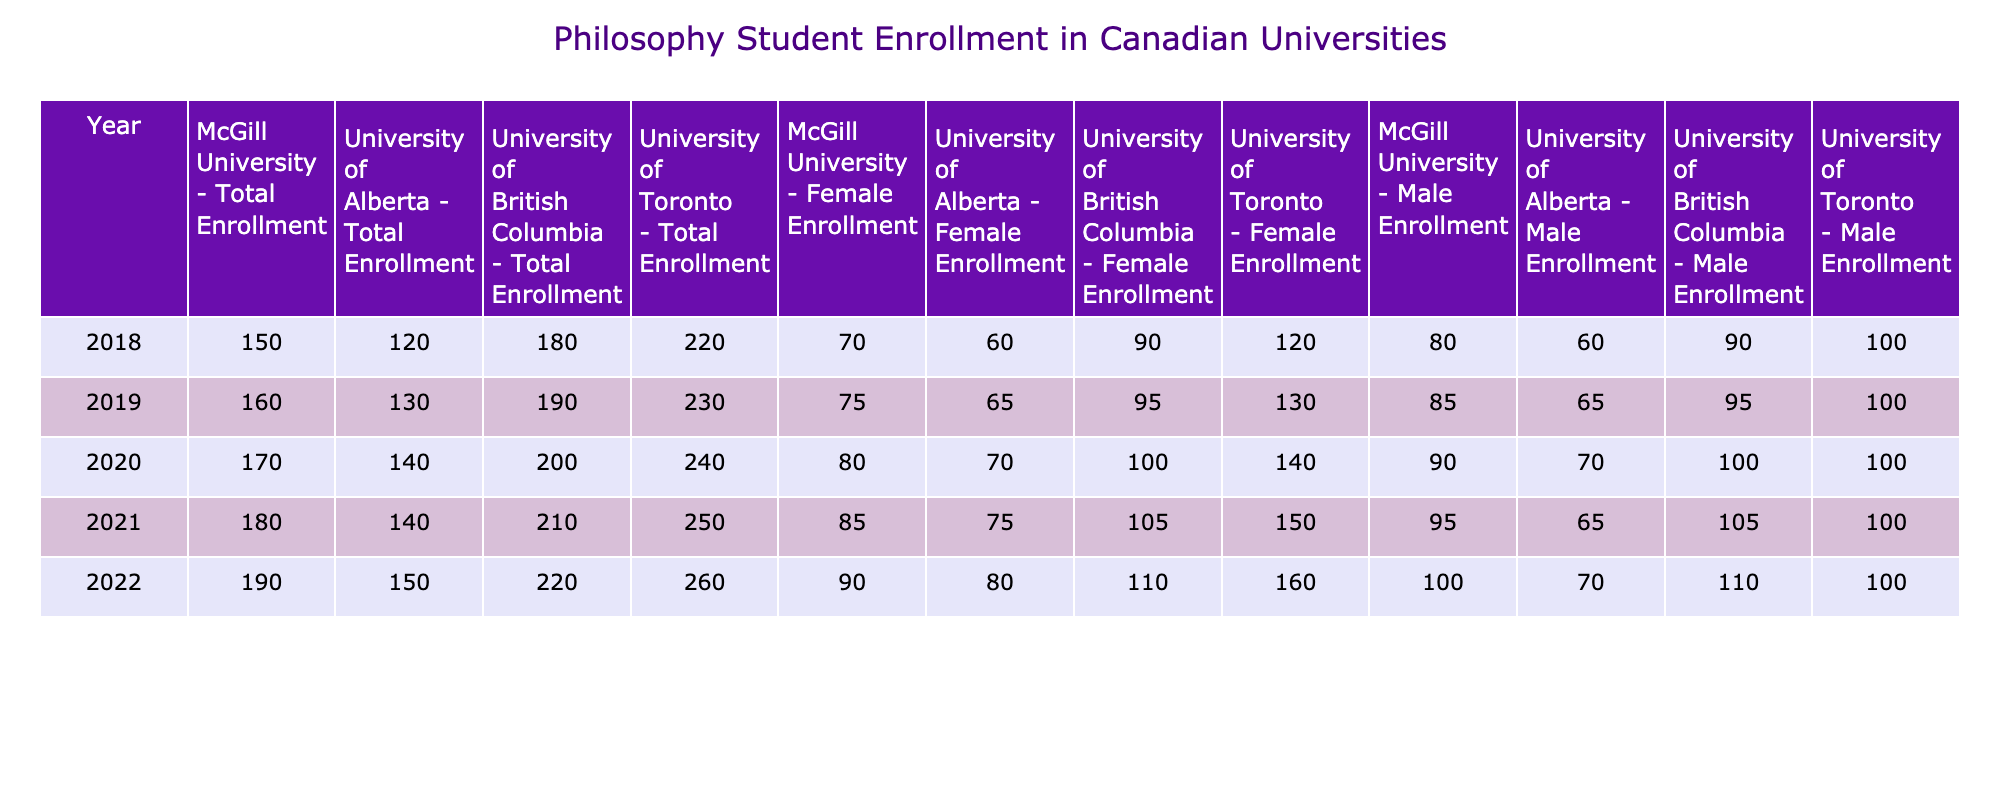What was the total enrollment of philosophy students at the University of Toronto in 2022? The value for Total Enrollment at the University of Toronto in 2022 is directly found in the table under the corresponding column, which shows it as 260.
Answer: 260 Which university had the highest number of female philosophy students in 2021? In 2021, the female enrollment numbers are compared across universities. The University of Toronto has 150, the University of British Columbia has 105, McGill University has 85, and the University of Alberta has 75. The highest is the University of Toronto with 150 female students.
Answer: University of Toronto What is the ratio of male to female philosophy students at McGill University in 2020? In 2020, McGill University had 80 male and 90 female philosophy students. The ratio is calculated by dividing the male enrollment by the female enrollment: 80/90, which simplifies to 8/9.
Answer: 8:9 Did the total number of philosophy students at the University of Alberta increase each year from 2018 to 2022? Checking the yearly total enrollment for the University of Alberta shows: 120 (2018), 130 (2019), 140 (2020), 140 (2021), and 150 (2022). The numbers do not show a consistently increasing trend because the total enrollment stayed the same in 2021 compared to 2020.
Answer: No How many more female philosophy students were enrolled at the University of British Columbia in 2022 compared to 2018? The number of female philosophy students in 2022 at UBC is 110, and in 2018 it was 90. The difference is calculated as 110 - 90 = 20.
Answer: 20 What was the total male enrollment across all listed universities in 2019? The total male enrollment for 2019 can be calculated by summing the male enrollments for each university: 100 (Toronto) + 95 (UBC) + 85 (McGill) + 65 (Alberta) = 445 total male students.
Answer: 445 In which year did the University of Alberta see the first increase in total enrollment? The University of Alberta has total enrollment numbers of 120 (2018) and 130 (2019) initially. The first increase after 2018 is thus noticed between 2018 and 2019.
Answer: 2019 What was the average female enrollment across all universities in 2020? The female enrollments in 2020 were: 140 (Toronto), 100 (UBC), 80 (McGill), and 70 (Alberta). Adding these gives 140 + 100 + 80 + 70 = 390. There are 4 universities, so the average is 390 / 4 = 97.5.
Answer: 97.5 